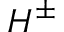<formula> <loc_0><loc_0><loc_500><loc_500>H ^ { \pm }</formula> 